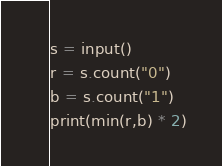Convert code to text. <code><loc_0><loc_0><loc_500><loc_500><_Python_>s = input()
r = s.count("0")
b = s.count("1")
print(min(r,b) * 2)
</code> 